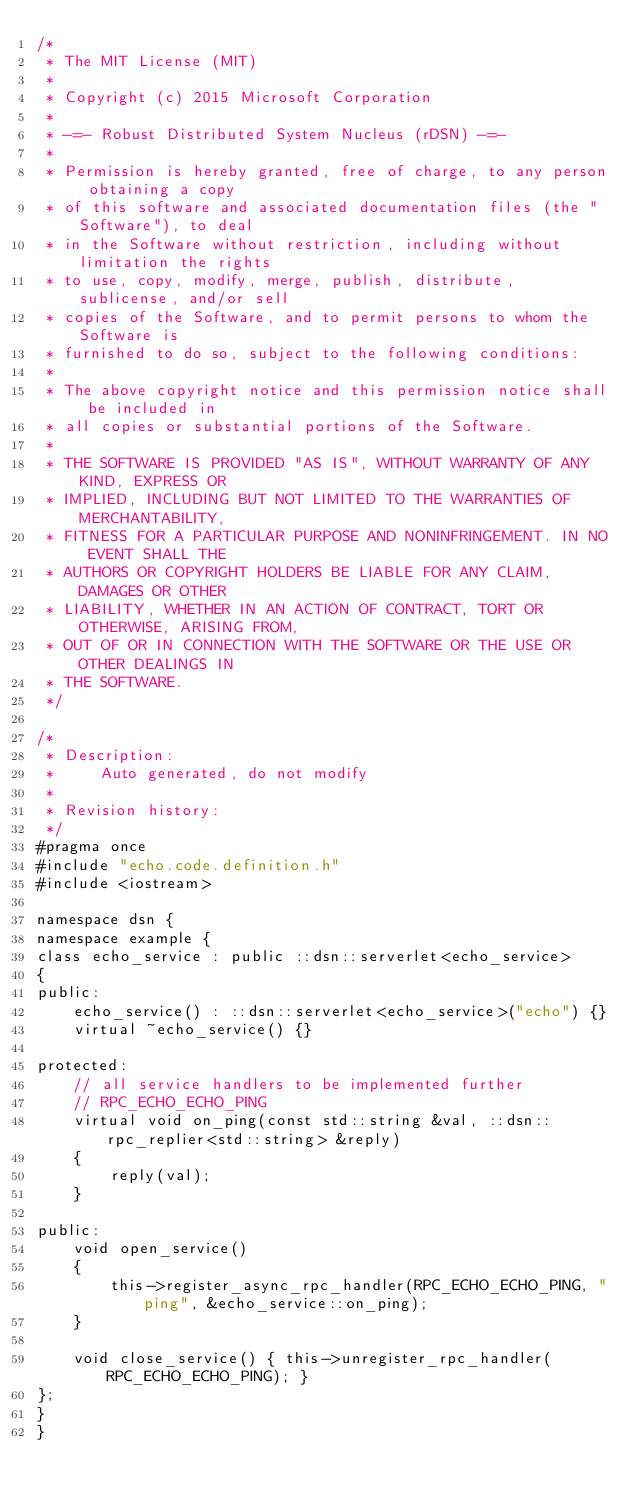<code> <loc_0><loc_0><loc_500><loc_500><_C_>/*
 * The MIT License (MIT)
 *
 * Copyright (c) 2015 Microsoft Corporation
 *
 * -=- Robust Distributed System Nucleus (rDSN) -=-
 *
 * Permission is hereby granted, free of charge, to any person obtaining a copy
 * of this software and associated documentation files (the "Software"), to deal
 * in the Software without restriction, including without limitation the rights
 * to use, copy, modify, merge, publish, distribute, sublicense, and/or sell
 * copies of the Software, and to permit persons to whom the Software is
 * furnished to do so, subject to the following conditions:
 *
 * The above copyright notice and this permission notice shall be included in
 * all copies or substantial portions of the Software.
 *
 * THE SOFTWARE IS PROVIDED "AS IS", WITHOUT WARRANTY OF ANY KIND, EXPRESS OR
 * IMPLIED, INCLUDING BUT NOT LIMITED TO THE WARRANTIES OF MERCHANTABILITY,
 * FITNESS FOR A PARTICULAR PURPOSE AND NONINFRINGEMENT. IN NO EVENT SHALL THE
 * AUTHORS OR COPYRIGHT HOLDERS BE LIABLE FOR ANY CLAIM, DAMAGES OR OTHER
 * LIABILITY, WHETHER IN AN ACTION OF CONTRACT, TORT OR OTHERWISE, ARISING FROM,
 * OUT OF OR IN CONNECTION WITH THE SOFTWARE OR THE USE OR OTHER DEALINGS IN
 * THE SOFTWARE.
 */

/*
 * Description:
 *     Auto generated, do not modify
 *
 * Revision history:
 */
#pragma once
#include "echo.code.definition.h"
#include <iostream>

namespace dsn {
namespace example {
class echo_service : public ::dsn::serverlet<echo_service>
{
public:
    echo_service() : ::dsn::serverlet<echo_service>("echo") {}
    virtual ~echo_service() {}

protected:
    // all service handlers to be implemented further
    // RPC_ECHO_ECHO_PING
    virtual void on_ping(const std::string &val, ::dsn::rpc_replier<std::string> &reply)
    {
        reply(val);
    }

public:
    void open_service()
    {
        this->register_async_rpc_handler(RPC_ECHO_ECHO_PING, "ping", &echo_service::on_ping);
    }

    void close_service() { this->unregister_rpc_handler(RPC_ECHO_ECHO_PING); }
};
}
}</code> 